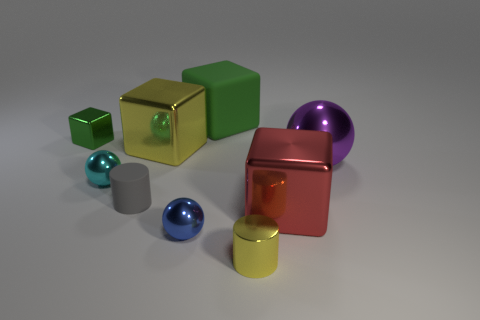Add 1 large things. How many objects exist? 10 Subtract all blocks. How many objects are left? 5 Add 8 gray things. How many gray things are left? 9 Add 7 small cyan shiny spheres. How many small cyan shiny spheres exist? 8 Subtract 1 purple spheres. How many objects are left? 8 Subtract all big brown spheres. Subtract all big matte things. How many objects are left? 8 